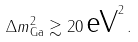Convert formula to latex. <formula><loc_0><loc_0><loc_500><loc_500>\Delta { m } ^ { 2 } _ { \text {Ga} } \gtrsim 2 0 \, \text {eV} ^ { 2 } \, .</formula> 